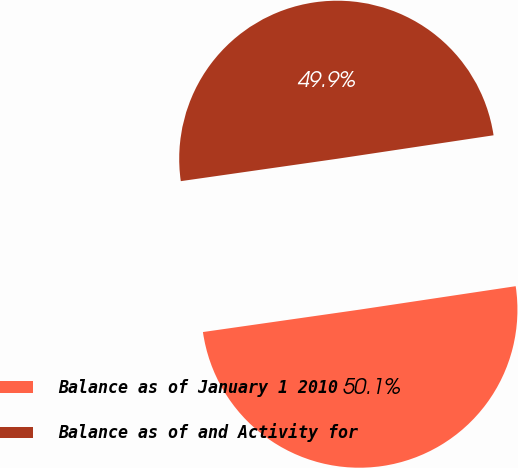<chart> <loc_0><loc_0><loc_500><loc_500><pie_chart><fcel>Balance as of January 1 2010<fcel>Balance as of and Activity for<nl><fcel>50.11%<fcel>49.89%<nl></chart> 